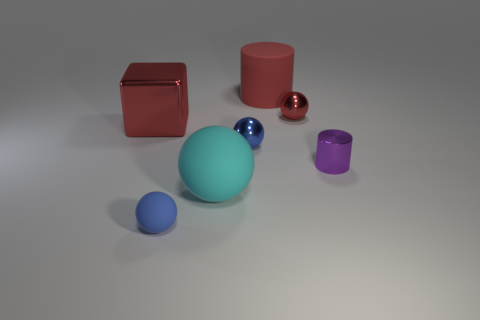Can you describe the shapes and colors of the objects in the image? Certainly! In the image, there is a collection of geometric shapes. You can see a large teal sphere, a smaller sea blue ball, a burgundy sphere with a reflective surface, a tall crimson cylinder, a small mauve cylinder, and a shiny ruby cube. 